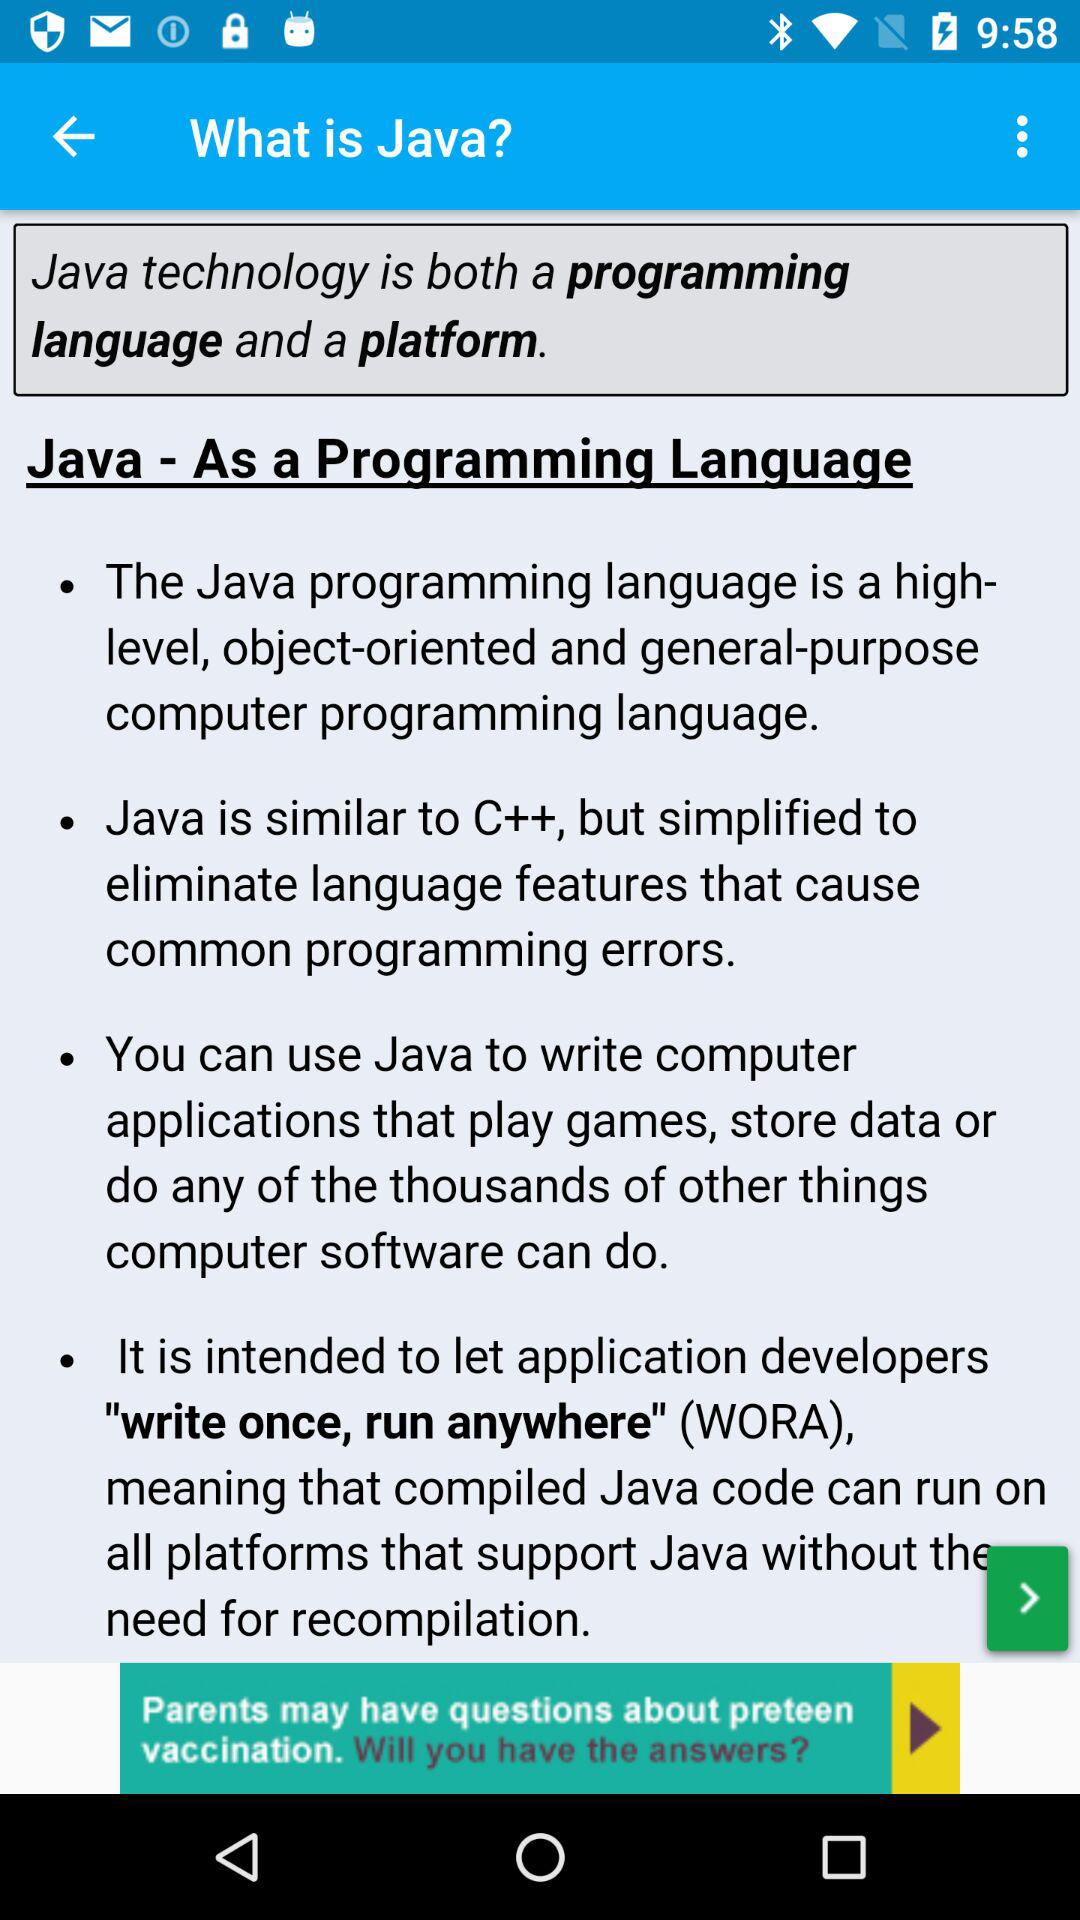What is the name of the mentioned programming language? The name of the mentioned programming language is Java. 